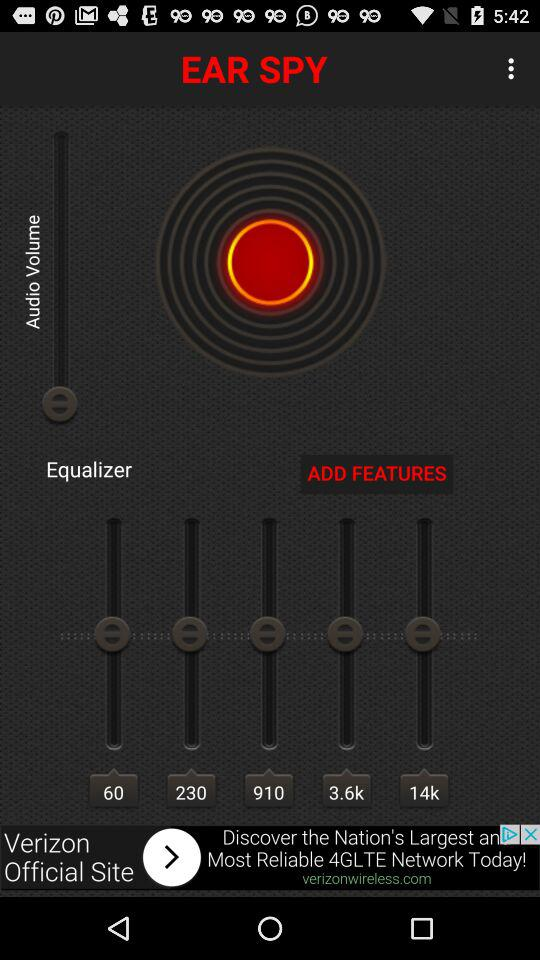What is the application name? The application name is "EAR SPY". 